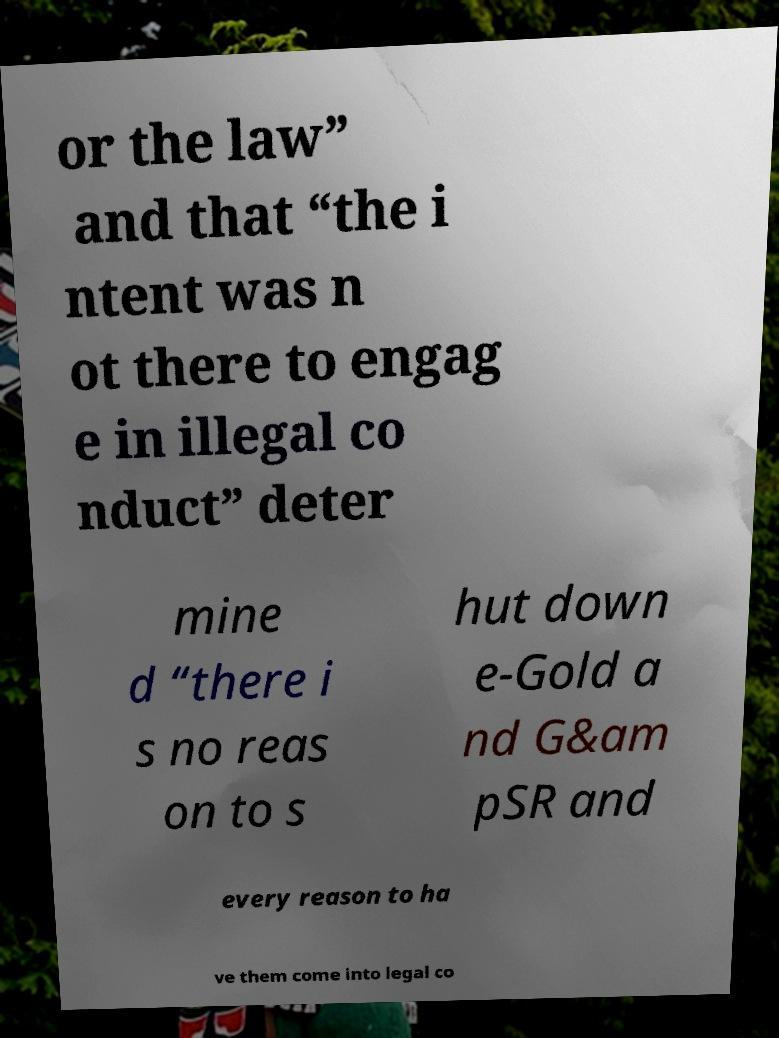There's text embedded in this image that I need extracted. Can you transcribe it verbatim? or the law” and that “the i ntent was n ot there to engag e in illegal co nduct” deter mine d “there i s no reas on to s hut down e-Gold a nd G&am pSR and every reason to ha ve them come into legal co 